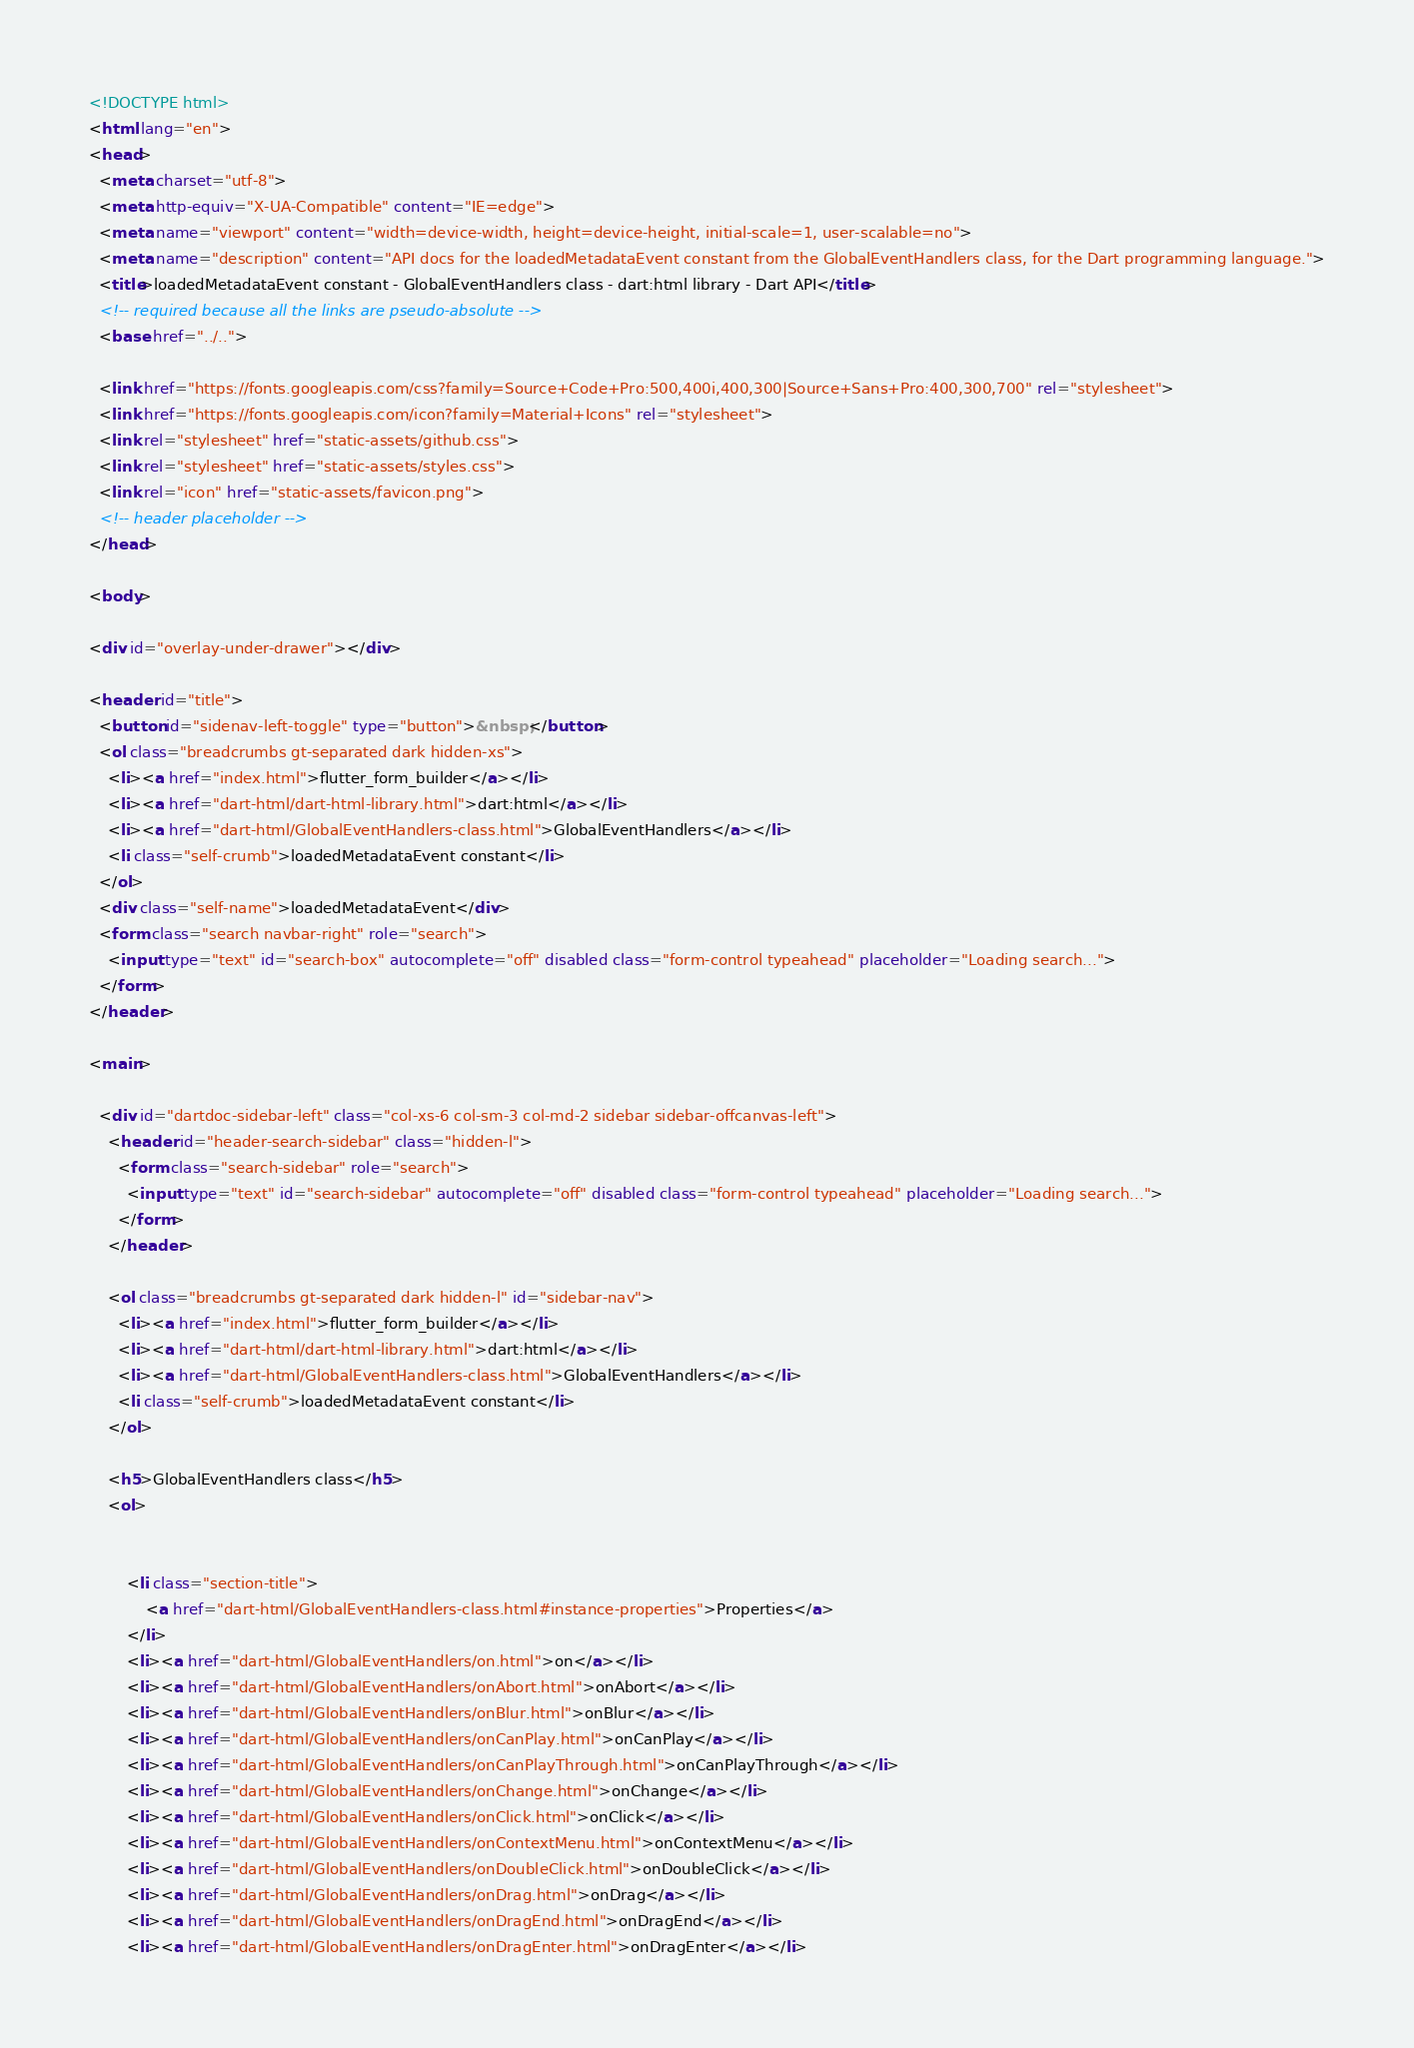<code> <loc_0><loc_0><loc_500><loc_500><_HTML_><!DOCTYPE html>
<html lang="en">
<head>
  <meta charset="utf-8">
  <meta http-equiv="X-UA-Compatible" content="IE=edge">
  <meta name="viewport" content="width=device-width, height=device-height, initial-scale=1, user-scalable=no">
  <meta name="description" content="API docs for the loadedMetadataEvent constant from the GlobalEventHandlers class, for the Dart programming language.">
  <title>loadedMetadataEvent constant - GlobalEventHandlers class - dart:html library - Dart API</title>
  <!-- required because all the links are pseudo-absolute -->
  <base href="../..">

  <link href="https://fonts.googleapis.com/css?family=Source+Code+Pro:500,400i,400,300|Source+Sans+Pro:400,300,700" rel="stylesheet">
  <link href="https://fonts.googleapis.com/icon?family=Material+Icons" rel="stylesheet">
  <link rel="stylesheet" href="static-assets/github.css">
  <link rel="stylesheet" href="static-assets/styles.css">
  <link rel="icon" href="static-assets/favicon.png">
  <!-- header placeholder -->
</head>

<body>

<div id="overlay-under-drawer"></div>

<header id="title">
  <button id="sidenav-left-toggle" type="button">&nbsp;</button>
  <ol class="breadcrumbs gt-separated dark hidden-xs">
    <li><a href="index.html">flutter_form_builder</a></li>
    <li><a href="dart-html/dart-html-library.html">dart:html</a></li>
    <li><a href="dart-html/GlobalEventHandlers-class.html">GlobalEventHandlers</a></li>
    <li class="self-crumb">loadedMetadataEvent constant</li>
  </ol>
  <div class="self-name">loadedMetadataEvent</div>
  <form class="search navbar-right" role="search">
    <input type="text" id="search-box" autocomplete="off" disabled class="form-control typeahead" placeholder="Loading search...">
  </form>
</header>

<main>

  <div id="dartdoc-sidebar-left" class="col-xs-6 col-sm-3 col-md-2 sidebar sidebar-offcanvas-left">
    <header id="header-search-sidebar" class="hidden-l">
      <form class="search-sidebar" role="search">
        <input type="text" id="search-sidebar" autocomplete="off" disabled class="form-control typeahead" placeholder="Loading search...">
      </form>
    </header>
    
    <ol class="breadcrumbs gt-separated dark hidden-l" id="sidebar-nav">
      <li><a href="index.html">flutter_form_builder</a></li>
      <li><a href="dart-html/dart-html-library.html">dart:html</a></li>
      <li><a href="dart-html/GlobalEventHandlers-class.html">GlobalEventHandlers</a></li>
      <li class="self-crumb">loadedMetadataEvent constant</li>
    </ol>
    
    <h5>GlobalEventHandlers class</h5>
    <ol>
    
    
        <li class="section-title">
            <a href="dart-html/GlobalEventHandlers-class.html#instance-properties">Properties</a>
        </li>
        <li><a href="dart-html/GlobalEventHandlers/on.html">on</a></li>
        <li><a href="dart-html/GlobalEventHandlers/onAbort.html">onAbort</a></li>
        <li><a href="dart-html/GlobalEventHandlers/onBlur.html">onBlur</a></li>
        <li><a href="dart-html/GlobalEventHandlers/onCanPlay.html">onCanPlay</a></li>
        <li><a href="dart-html/GlobalEventHandlers/onCanPlayThrough.html">onCanPlayThrough</a></li>
        <li><a href="dart-html/GlobalEventHandlers/onChange.html">onChange</a></li>
        <li><a href="dart-html/GlobalEventHandlers/onClick.html">onClick</a></li>
        <li><a href="dart-html/GlobalEventHandlers/onContextMenu.html">onContextMenu</a></li>
        <li><a href="dart-html/GlobalEventHandlers/onDoubleClick.html">onDoubleClick</a></li>
        <li><a href="dart-html/GlobalEventHandlers/onDrag.html">onDrag</a></li>
        <li><a href="dart-html/GlobalEventHandlers/onDragEnd.html">onDragEnd</a></li>
        <li><a href="dart-html/GlobalEventHandlers/onDragEnter.html">onDragEnter</a></li></code> 